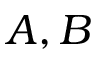<formula> <loc_0><loc_0><loc_500><loc_500>A , B</formula> 